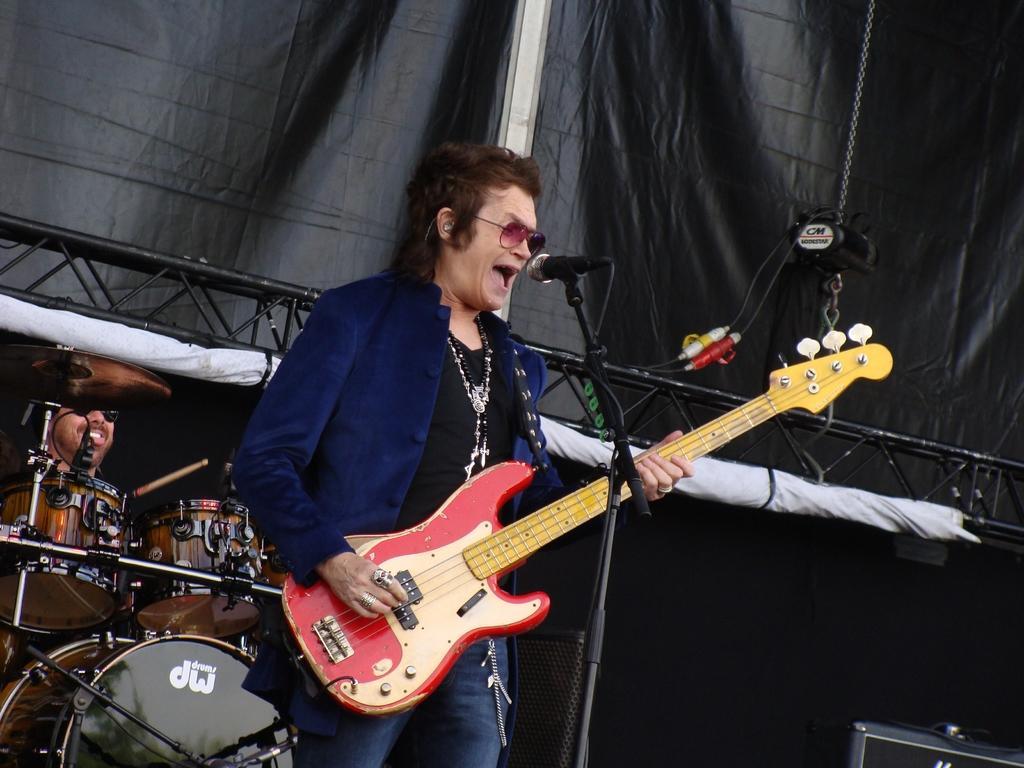Can you describe this image briefly? In the center we can see one man holding guitar,in front of him we can see microphone. And coming to background we can see sheet and few more musical instruments. 